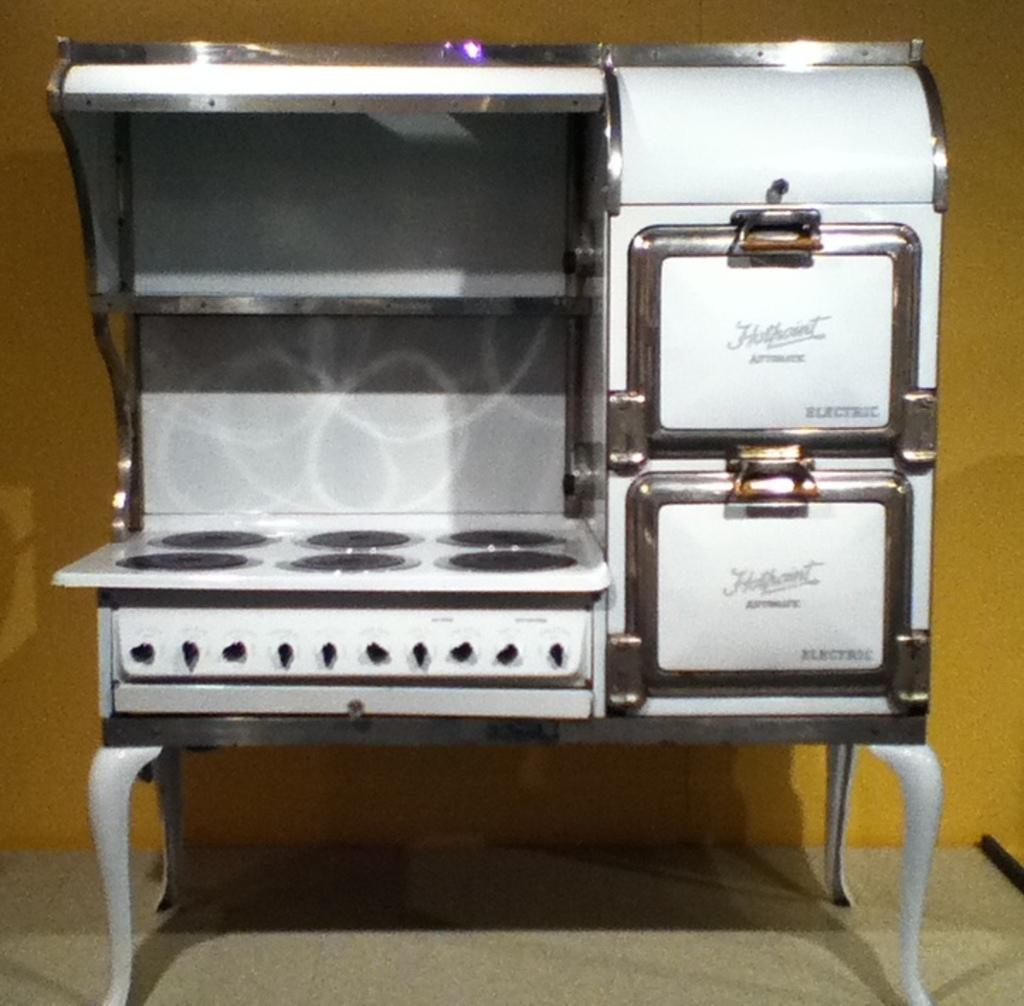What appliance can be seen in the image? There is a food warmer in the image. What type of flooring is present in the image? There is a carpet on the floor in the image. What color is the wall in the background of the image? There is a yellow color wall in the background of the image. Can you see any snakes slithering on the carpet in the image? There are no snakes present in the image; it only features a food warmer, carpet, and a yellow wall. 